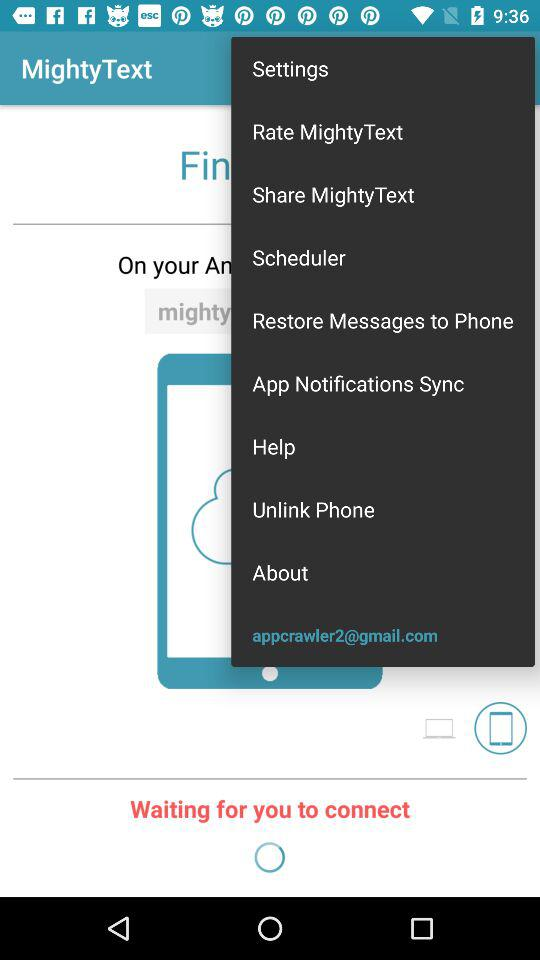What application is asking for permission? The application is "MightyText". 